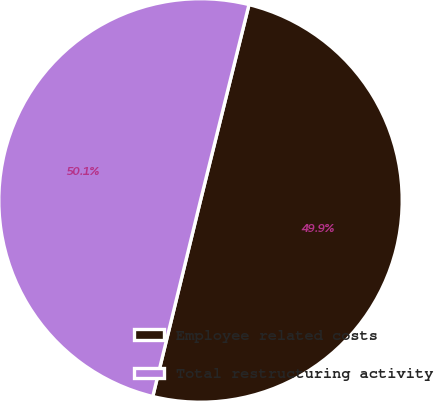<chart> <loc_0><loc_0><loc_500><loc_500><pie_chart><fcel>Employee related costs<fcel>Total restructuring activity<nl><fcel>49.94%<fcel>50.06%<nl></chart> 